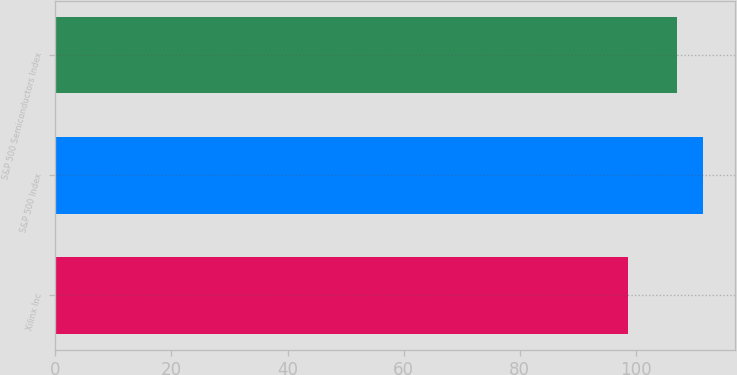<chart> <loc_0><loc_0><loc_500><loc_500><bar_chart><fcel>Xilinx Inc<fcel>S&P 500 Index<fcel>S&P 500 Semiconductors Index<nl><fcel>98.57<fcel>111.49<fcel>107<nl></chart> 